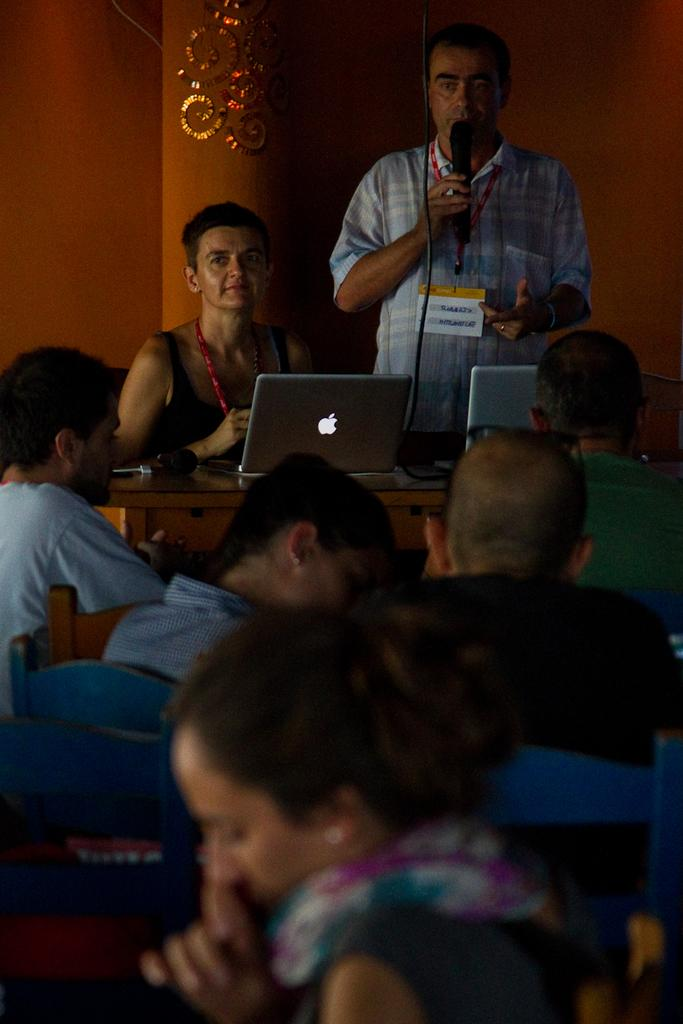What are the people in the image doing? The people in the image are sitting. What object can be seen on the table in the image? There is a microphone and a laptop on the table in the image. What is the standing man holding in the image? The standing man is holding a microphone in the image. What type of carriage can be seen in the image? There is no carriage present in the image. What is the condition of the turkey in the image? There is no turkey present in the image. 